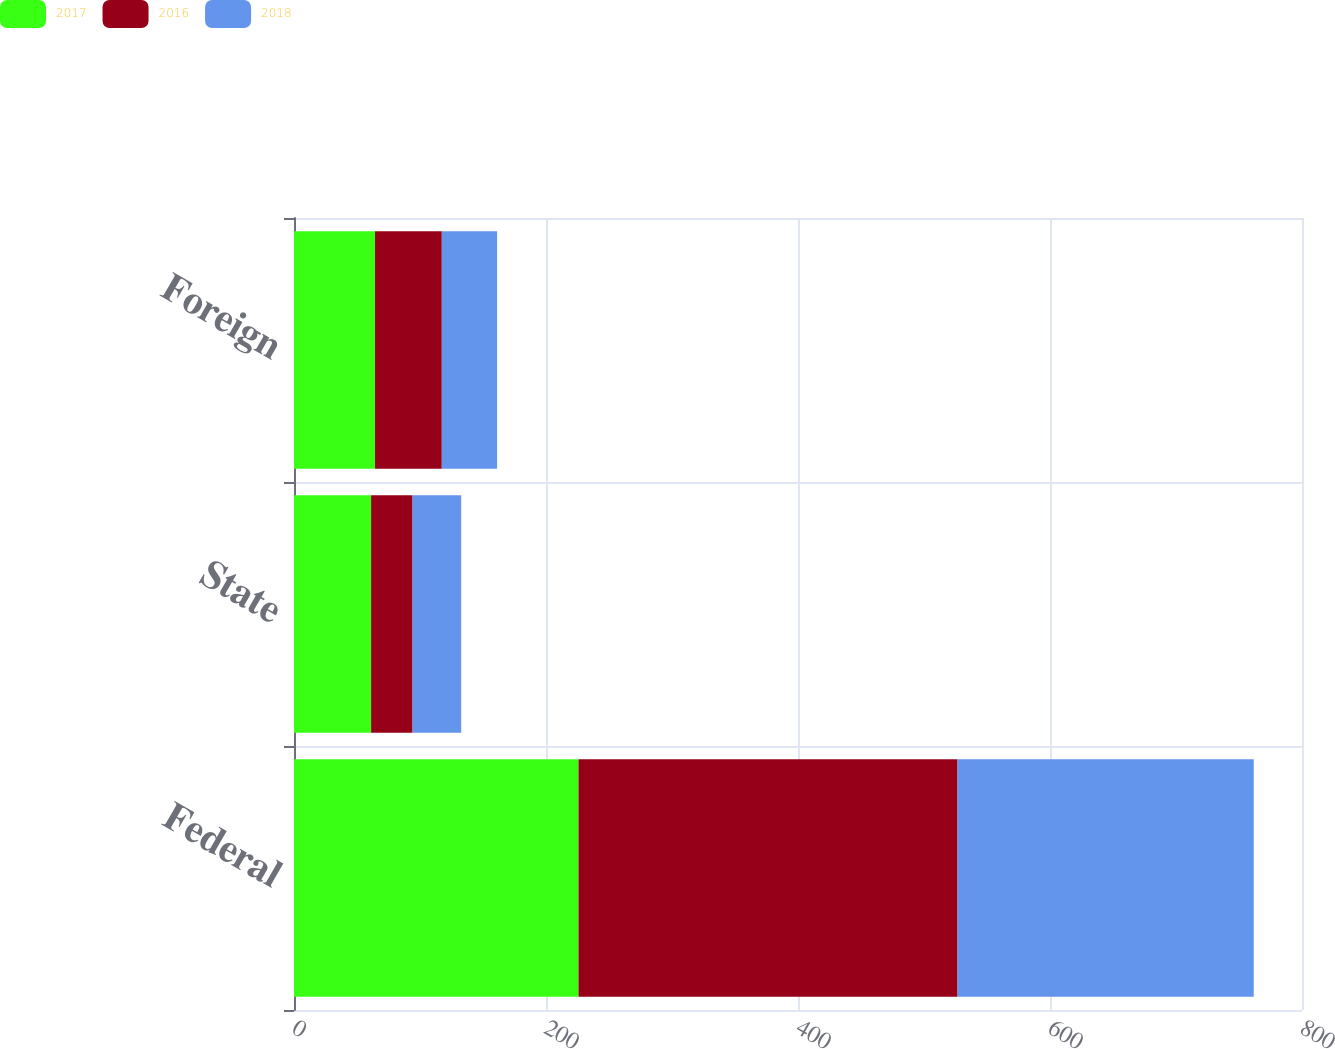Convert chart to OTSL. <chart><loc_0><loc_0><loc_500><loc_500><stacked_bar_chart><ecel><fcel>Federal<fcel>State<fcel>Foreign<nl><fcel>2017<fcel>225.8<fcel>61.2<fcel>64.3<nl><fcel>2016<fcel>300.8<fcel>32.9<fcel>53<nl><fcel>2018<fcel>235.1<fcel>38.6<fcel>43.9<nl></chart> 